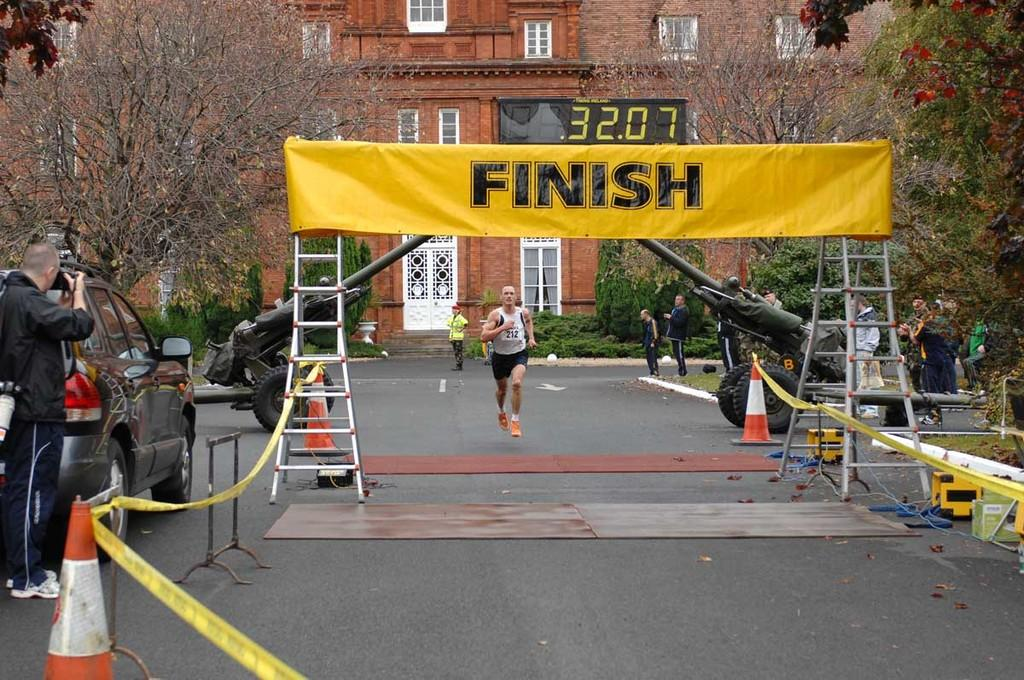<image>
Render a clear and concise summary of the photo. the end of a marathon with a banner up that says 'finish' 